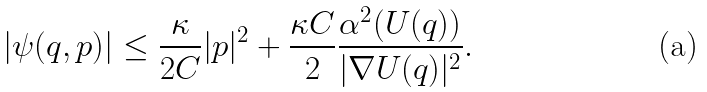Convert formula to latex. <formula><loc_0><loc_0><loc_500><loc_500>| \psi ( q , p ) | \leq \frac { \kappa } { 2 C } | p | ^ { 2 } + \frac { \kappa C } { 2 } \frac { \alpha ^ { 2 } ( U ( q ) ) } { | \nabla U ( q ) | ^ { 2 } } .</formula> 